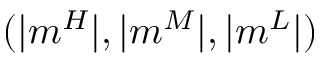Convert formula to latex. <formula><loc_0><loc_0><loc_500><loc_500>( | m ^ { H } | , | m ^ { M } | , | m ^ { L } | )</formula> 